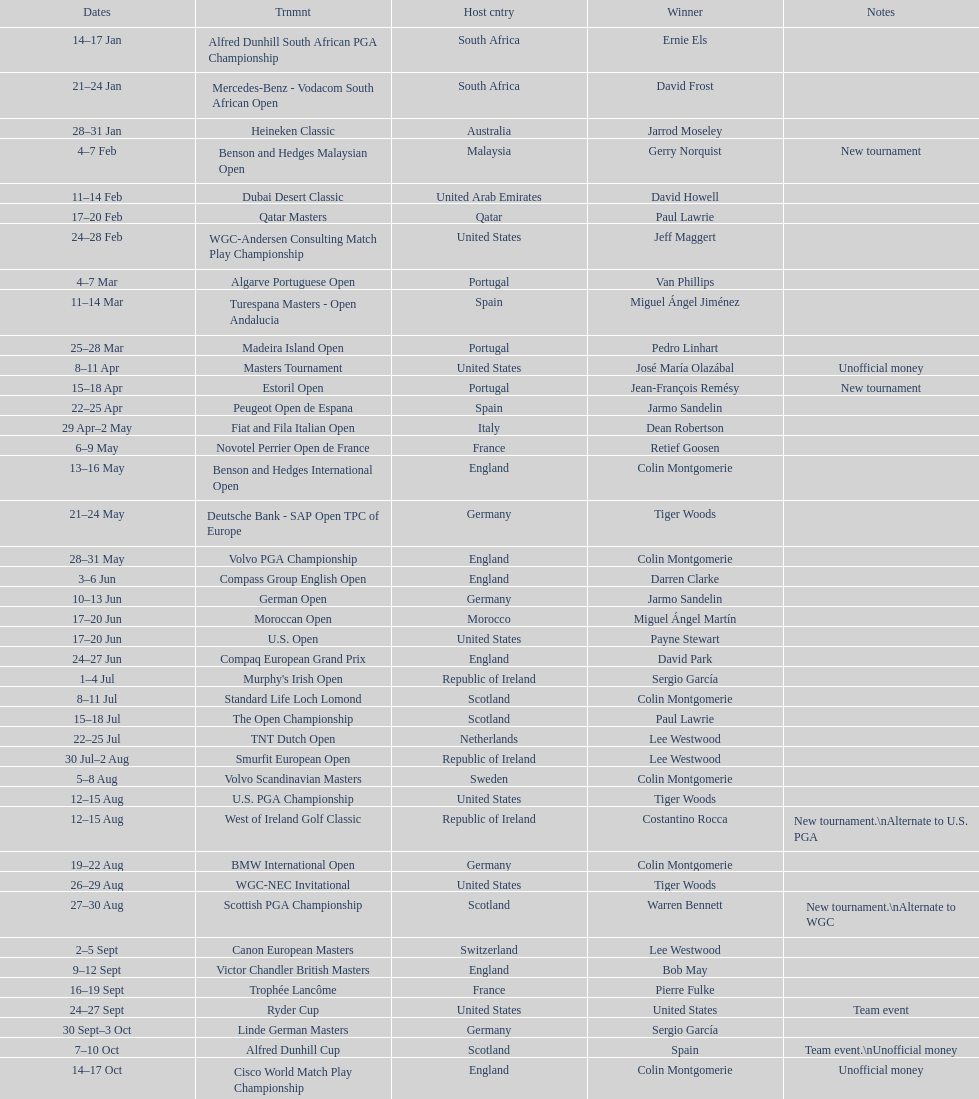Which winner won more tournaments, jeff maggert or tiger woods? Tiger Woods. 